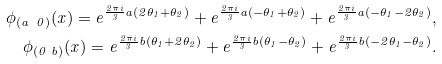Convert formula to latex. <formula><loc_0><loc_0><loc_500><loc_500>\phi _ { ( a \ 0 ) } ( x ) = e ^ { \frac { 2 \pi i } 3 a ( 2 \theta _ { 1 } + \theta _ { 2 } ) } + e ^ { \frac { 2 \pi i } 3 a ( - \theta _ { 1 } + \theta _ { 2 } ) } + e ^ { \frac { 2 \pi i } 3 a ( - \theta _ { 1 } - 2 \theta _ { 2 } ) } , \\ \phi _ { ( 0 \ b ) } ( x ) = e ^ { \frac { 2 \pi i } 3 b ( \theta _ { 1 } + 2 \theta _ { 2 } ) } + e ^ { \frac { 2 \pi i } 3 b ( \theta _ { 1 } - \theta _ { 2 } ) } + e ^ { \frac { 2 \pi i } 3 b ( - 2 \theta _ { 1 } - \theta _ { 2 } ) } .</formula> 